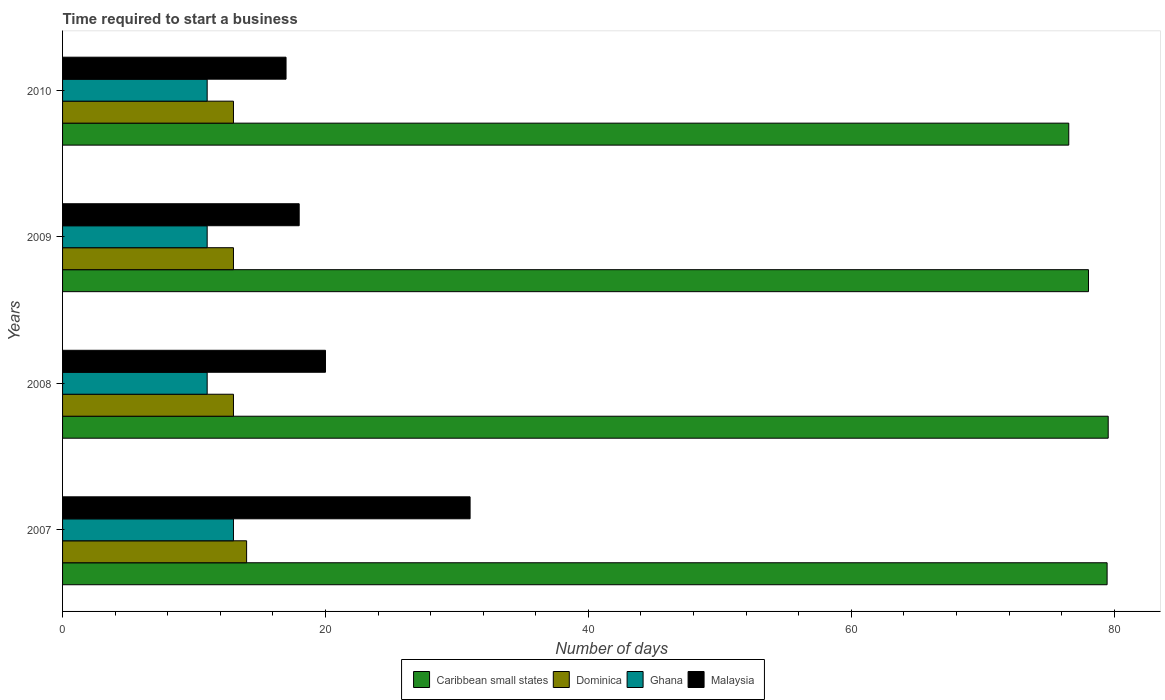Are the number of bars per tick equal to the number of legend labels?
Make the answer very short. Yes. How many bars are there on the 4th tick from the top?
Offer a terse response. 4. How many bars are there on the 3rd tick from the bottom?
Ensure brevity in your answer.  4. What is the label of the 2nd group of bars from the top?
Provide a short and direct response. 2009. In how many cases, is the number of bars for a given year not equal to the number of legend labels?
Your answer should be compact. 0. What is the number of days required to start a business in Ghana in 2009?
Your response must be concise. 11. Across all years, what is the maximum number of days required to start a business in Malaysia?
Ensure brevity in your answer.  31. Across all years, what is the minimum number of days required to start a business in Caribbean small states?
Provide a short and direct response. 76.54. In which year was the number of days required to start a business in Ghana minimum?
Provide a succinct answer. 2008. What is the average number of days required to start a business in Malaysia per year?
Ensure brevity in your answer.  21.5. In the year 2007, what is the difference between the number of days required to start a business in Ghana and number of days required to start a business in Dominica?
Your answer should be very brief. -1. Is the difference between the number of days required to start a business in Ghana in 2008 and 2010 greater than the difference between the number of days required to start a business in Dominica in 2008 and 2010?
Keep it short and to the point. No. What is the difference between the highest and the second highest number of days required to start a business in Caribbean small states?
Your answer should be very brief. 0.08. What is the difference between the highest and the lowest number of days required to start a business in Caribbean small states?
Your answer should be compact. 3. Is it the case that in every year, the sum of the number of days required to start a business in Dominica and number of days required to start a business in Malaysia is greater than the sum of number of days required to start a business in Caribbean small states and number of days required to start a business in Ghana?
Your answer should be very brief. Yes. What does the 1st bar from the top in 2008 represents?
Offer a very short reply. Malaysia. What does the 4th bar from the bottom in 2009 represents?
Keep it short and to the point. Malaysia. Is it the case that in every year, the sum of the number of days required to start a business in Dominica and number of days required to start a business in Caribbean small states is greater than the number of days required to start a business in Ghana?
Your answer should be very brief. Yes. How many bars are there?
Offer a terse response. 16. Are all the bars in the graph horizontal?
Provide a succinct answer. Yes. Are the values on the major ticks of X-axis written in scientific E-notation?
Your answer should be very brief. No. Does the graph contain grids?
Provide a succinct answer. No. How are the legend labels stacked?
Offer a terse response. Horizontal. What is the title of the graph?
Your response must be concise. Time required to start a business. Does "Philippines" appear as one of the legend labels in the graph?
Make the answer very short. No. What is the label or title of the X-axis?
Offer a terse response. Number of days. What is the label or title of the Y-axis?
Keep it short and to the point. Years. What is the Number of days of Caribbean small states in 2007?
Provide a short and direct response. 79.46. What is the Number of days of Malaysia in 2007?
Provide a succinct answer. 31. What is the Number of days in Caribbean small states in 2008?
Offer a terse response. 79.54. What is the Number of days of Ghana in 2008?
Provide a short and direct response. 11. What is the Number of days in Malaysia in 2008?
Your answer should be very brief. 20. What is the Number of days of Caribbean small states in 2009?
Your answer should be very brief. 78.04. What is the Number of days of Dominica in 2009?
Your response must be concise. 13. What is the Number of days of Ghana in 2009?
Give a very brief answer. 11. What is the Number of days in Malaysia in 2009?
Your answer should be very brief. 18. What is the Number of days in Caribbean small states in 2010?
Give a very brief answer. 76.54. What is the Number of days in Dominica in 2010?
Give a very brief answer. 13. What is the Number of days in Malaysia in 2010?
Ensure brevity in your answer.  17. Across all years, what is the maximum Number of days in Caribbean small states?
Offer a very short reply. 79.54. Across all years, what is the maximum Number of days in Ghana?
Offer a very short reply. 13. Across all years, what is the maximum Number of days in Malaysia?
Your response must be concise. 31. Across all years, what is the minimum Number of days of Caribbean small states?
Ensure brevity in your answer.  76.54. What is the total Number of days of Caribbean small states in the graph?
Offer a terse response. 313.58. What is the total Number of days of Dominica in the graph?
Offer a very short reply. 53. What is the total Number of days of Ghana in the graph?
Your answer should be compact. 46. What is the total Number of days in Malaysia in the graph?
Keep it short and to the point. 86. What is the difference between the Number of days in Caribbean small states in 2007 and that in 2008?
Ensure brevity in your answer.  -0.08. What is the difference between the Number of days in Ghana in 2007 and that in 2008?
Your answer should be compact. 2. What is the difference between the Number of days of Caribbean small states in 2007 and that in 2009?
Provide a succinct answer. 1.42. What is the difference between the Number of days of Dominica in 2007 and that in 2009?
Provide a short and direct response. 1. What is the difference between the Number of days of Ghana in 2007 and that in 2009?
Keep it short and to the point. 2. What is the difference between the Number of days of Malaysia in 2007 and that in 2009?
Ensure brevity in your answer.  13. What is the difference between the Number of days of Caribbean small states in 2007 and that in 2010?
Provide a short and direct response. 2.92. What is the difference between the Number of days in Malaysia in 2007 and that in 2010?
Provide a succinct answer. 14. What is the difference between the Number of days of Dominica in 2008 and that in 2009?
Keep it short and to the point. 0. What is the difference between the Number of days in Ghana in 2008 and that in 2009?
Your answer should be very brief. 0. What is the difference between the Number of days of Malaysia in 2008 and that in 2009?
Keep it short and to the point. 2. What is the difference between the Number of days of Ghana in 2008 and that in 2010?
Offer a terse response. 0. What is the difference between the Number of days of Caribbean small states in 2009 and that in 2010?
Offer a very short reply. 1.5. What is the difference between the Number of days in Dominica in 2009 and that in 2010?
Offer a terse response. 0. What is the difference between the Number of days in Ghana in 2009 and that in 2010?
Keep it short and to the point. 0. What is the difference between the Number of days in Caribbean small states in 2007 and the Number of days in Dominica in 2008?
Provide a short and direct response. 66.46. What is the difference between the Number of days in Caribbean small states in 2007 and the Number of days in Ghana in 2008?
Your answer should be compact. 68.46. What is the difference between the Number of days in Caribbean small states in 2007 and the Number of days in Malaysia in 2008?
Your answer should be compact. 59.46. What is the difference between the Number of days in Dominica in 2007 and the Number of days in Malaysia in 2008?
Your answer should be very brief. -6. What is the difference between the Number of days of Caribbean small states in 2007 and the Number of days of Dominica in 2009?
Your response must be concise. 66.46. What is the difference between the Number of days of Caribbean small states in 2007 and the Number of days of Ghana in 2009?
Your answer should be compact. 68.46. What is the difference between the Number of days of Caribbean small states in 2007 and the Number of days of Malaysia in 2009?
Offer a very short reply. 61.46. What is the difference between the Number of days of Ghana in 2007 and the Number of days of Malaysia in 2009?
Your response must be concise. -5. What is the difference between the Number of days of Caribbean small states in 2007 and the Number of days of Dominica in 2010?
Offer a terse response. 66.46. What is the difference between the Number of days of Caribbean small states in 2007 and the Number of days of Ghana in 2010?
Make the answer very short. 68.46. What is the difference between the Number of days in Caribbean small states in 2007 and the Number of days in Malaysia in 2010?
Provide a succinct answer. 62.46. What is the difference between the Number of days in Dominica in 2007 and the Number of days in Malaysia in 2010?
Offer a terse response. -3. What is the difference between the Number of days of Ghana in 2007 and the Number of days of Malaysia in 2010?
Keep it short and to the point. -4. What is the difference between the Number of days in Caribbean small states in 2008 and the Number of days in Dominica in 2009?
Ensure brevity in your answer.  66.54. What is the difference between the Number of days of Caribbean small states in 2008 and the Number of days of Ghana in 2009?
Your answer should be very brief. 68.54. What is the difference between the Number of days of Caribbean small states in 2008 and the Number of days of Malaysia in 2009?
Offer a very short reply. 61.54. What is the difference between the Number of days of Dominica in 2008 and the Number of days of Ghana in 2009?
Offer a terse response. 2. What is the difference between the Number of days in Dominica in 2008 and the Number of days in Malaysia in 2009?
Ensure brevity in your answer.  -5. What is the difference between the Number of days of Caribbean small states in 2008 and the Number of days of Dominica in 2010?
Provide a short and direct response. 66.54. What is the difference between the Number of days of Caribbean small states in 2008 and the Number of days of Ghana in 2010?
Ensure brevity in your answer.  68.54. What is the difference between the Number of days of Caribbean small states in 2008 and the Number of days of Malaysia in 2010?
Make the answer very short. 62.54. What is the difference between the Number of days in Dominica in 2008 and the Number of days in Ghana in 2010?
Your answer should be compact. 2. What is the difference between the Number of days in Ghana in 2008 and the Number of days in Malaysia in 2010?
Keep it short and to the point. -6. What is the difference between the Number of days of Caribbean small states in 2009 and the Number of days of Dominica in 2010?
Provide a succinct answer. 65.04. What is the difference between the Number of days in Caribbean small states in 2009 and the Number of days in Ghana in 2010?
Keep it short and to the point. 67.04. What is the difference between the Number of days of Caribbean small states in 2009 and the Number of days of Malaysia in 2010?
Keep it short and to the point. 61.04. What is the difference between the Number of days of Dominica in 2009 and the Number of days of Ghana in 2010?
Give a very brief answer. 2. What is the average Number of days in Caribbean small states per year?
Your answer should be compact. 78.4. What is the average Number of days of Dominica per year?
Your response must be concise. 13.25. What is the average Number of days in Malaysia per year?
Offer a very short reply. 21.5. In the year 2007, what is the difference between the Number of days of Caribbean small states and Number of days of Dominica?
Provide a short and direct response. 65.46. In the year 2007, what is the difference between the Number of days in Caribbean small states and Number of days in Ghana?
Provide a short and direct response. 66.46. In the year 2007, what is the difference between the Number of days in Caribbean small states and Number of days in Malaysia?
Offer a very short reply. 48.46. In the year 2007, what is the difference between the Number of days in Dominica and Number of days in Malaysia?
Your response must be concise. -17. In the year 2008, what is the difference between the Number of days of Caribbean small states and Number of days of Dominica?
Make the answer very short. 66.54. In the year 2008, what is the difference between the Number of days in Caribbean small states and Number of days in Ghana?
Provide a succinct answer. 68.54. In the year 2008, what is the difference between the Number of days in Caribbean small states and Number of days in Malaysia?
Keep it short and to the point. 59.54. In the year 2008, what is the difference between the Number of days in Ghana and Number of days in Malaysia?
Keep it short and to the point. -9. In the year 2009, what is the difference between the Number of days in Caribbean small states and Number of days in Dominica?
Offer a terse response. 65.04. In the year 2009, what is the difference between the Number of days of Caribbean small states and Number of days of Ghana?
Give a very brief answer. 67.04. In the year 2009, what is the difference between the Number of days in Caribbean small states and Number of days in Malaysia?
Provide a short and direct response. 60.04. In the year 2009, what is the difference between the Number of days in Dominica and Number of days in Malaysia?
Offer a very short reply. -5. In the year 2010, what is the difference between the Number of days in Caribbean small states and Number of days in Dominica?
Offer a very short reply. 63.54. In the year 2010, what is the difference between the Number of days in Caribbean small states and Number of days in Ghana?
Your answer should be very brief. 65.54. In the year 2010, what is the difference between the Number of days of Caribbean small states and Number of days of Malaysia?
Keep it short and to the point. 59.54. In the year 2010, what is the difference between the Number of days of Dominica and Number of days of Ghana?
Give a very brief answer. 2. What is the ratio of the Number of days of Dominica in 2007 to that in 2008?
Keep it short and to the point. 1.08. What is the ratio of the Number of days of Ghana in 2007 to that in 2008?
Make the answer very short. 1.18. What is the ratio of the Number of days in Malaysia in 2007 to that in 2008?
Your answer should be compact. 1.55. What is the ratio of the Number of days of Caribbean small states in 2007 to that in 2009?
Keep it short and to the point. 1.02. What is the ratio of the Number of days in Ghana in 2007 to that in 2009?
Give a very brief answer. 1.18. What is the ratio of the Number of days in Malaysia in 2007 to that in 2009?
Your answer should be compact. 1.72. What is the ratio of the Number of days of Caribbean small states in 2007 to that in 2010?
Your answer should be very brief. 1.04. What is the ratio of the Number of days in Ghana in 2007 to that in 2010?
Your response must be concise. 1.18. What is the ratio of the Number of days of Malaysia in 2007 to that in 2010?
Your response must be concise. 1.82. What is the ratio of the Number of days of Caribbean small states in 2008 to that in 2009?
Ensure brevity in your answer.  1.02. What is the ratio of the Number of days in Dominica in 2008 to that in 2009?
Ensure brevity in your answer.  1. What is the ratio of the Number of days of Malaysia in 2008 to that in 2009?
Offer a very short reply. 1.11. What is the ratio of the Number of days in Caribbean small states in 2008 to that in 2010?
Provide a short and direct response. 1.04. What is the ratio of the Number of days of Ghana in 2008 to that in 2010?
Make the answer very short. 1. What is the ratio of the Number of days of Malaysia in 2008 to that in 2010?
Make the answer very short. 1.18. What is the ratio of the Number of days of Caribbean small states in 2009 to that in 2010?
Your response must be concise. 1.02. What is the ratio of the Number of days of Dominica in 2009 to that in 2010?
Your answer should be compact. 1. What is the ratio of the Number of days in Ghana in 2009 to that in 2010?
Your answer should be compact. 1. What is the ratio of the Number of days of Malaysia in 2009 to that in 2010?
Give a very brief answer. 1.06. What is the difference between the highest and the second highest Number of days in Caribbean small states?
Keep it short and to the point. 0.08. What is the difference between the highest and the second highest Number of days in Dominica?
Your answer should be very brief. 1. What is the difference between the highest and the second highest Number of days of Ghana?
Offer a terse response. 2. What is the difference between the highest and the lowest Number of days in Dominica?
Keep it short and to the point. 1. What is the difference between the highest and the lowest Number of days in Malaysia?
Offer a very short reply. 14. 